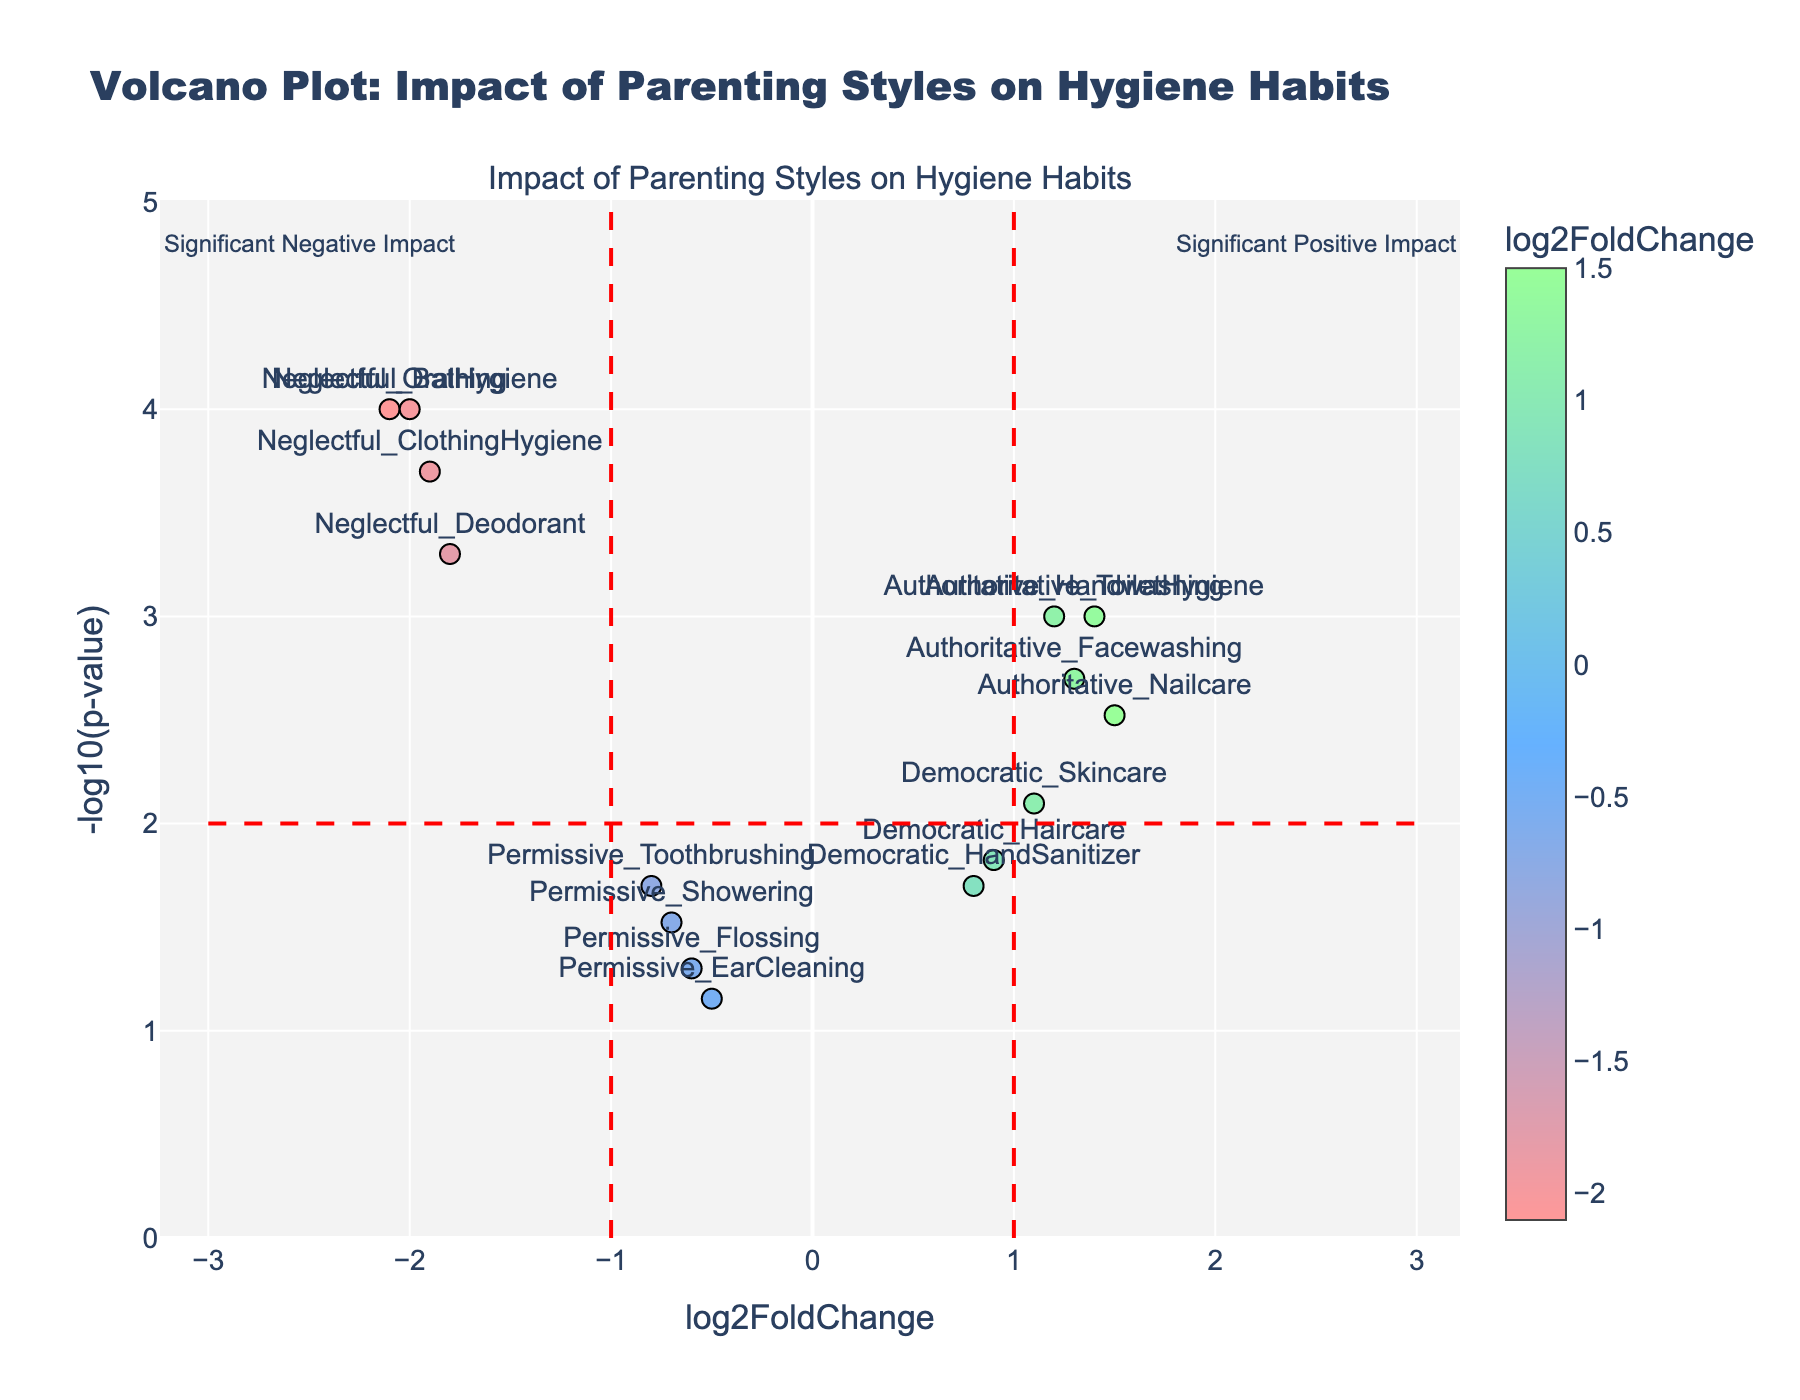what is the title of the plot? The title of the plot is displayed at the top and reads: "Volcano Plot: Impact of Parenting Styles on Hygiene Habits"
Answer: Volcano Plot: Impact of Parenting Styles on Hygiene Habits What color is used for the points with the highest log2 fold change? The color of the points with the highest log2 fold change appears in a vivid green color at the rightmost part of the color scale, indicating a higher value
Answer: Green How many data points are there in the plot? Each data point corresponds to a marker with a label. Counting these markers shows there are 14 data points in total.
Answer: 14 Which parenting style has the most significant negative impact on a hygiene habit? By locating the point with the largest negative log2 fold change and the highest -log10(p-value), the datapoint 'Neglectful_Bathing' appears to be the most extreme in the negative direction with -log10(p-value)
Answer: Neglectful_Bathing Which hygiene habit is most positively impacted by the authoritarian parenting style? To find the most positively impacted habit, locate the highest positive log2 fold change value among the 'Authoritative' labeled points. The point 'Authoritative_Nailcare' has the highest positive log2 fold change among this style
Answer: Nailcare What are the log2 fold change and p-value for permissive flossing? Hovering over the 'Permissive_Flossing' point or examining its coordinates reveals a log2 fold change of -0.6 and a p-value of 0.05
Answer: log2 fold change: -0.6, p-value: 0.05 What is the threshold for statistical significance in this plot? The significance threshold is shown by the horizontal dashed red line at y=-log10(p-value)=2, which corresponds to a p-value=0.01
Answer: p-value=0.01 Which data points fall into the "Significant Positive Impact" region? Points in the "Significant Positive Impact" region are those with a log2 fold change >1 and -log10(p-value) > 2, including 'Authoritative_ToiletHygiene', 'Authoritative_Handwashing', and 'Authoritative_Nailcare'
Answer: Authoritative_ToiletHygiene, Authoritative_Handwashing, Authoritative_Nailcare Which hygiene habits are poorly impacted by neglectful parenting? The data points 'Neglectful_Bathing', 'Neglectful_OralHygiene', and 'Neglectful_ClothingHygiene' are in the extreme negative region, indicating these habits are poorly impacted
Answer: Bathing, OralHygiene, ClothingHygiene Considering democratic parenting, what is the average log2 fold change for the associated hygiene habits? Averaging the log2 fold changes for 'Democratic_Haircare' (0.9), 'Democratic_Skincare' (1.1), and 'Democratic_HandSanitizer' (0.8) gives (0.9 + 1.1 + 0.8)/3 = 0.933
Answer: 0.933 